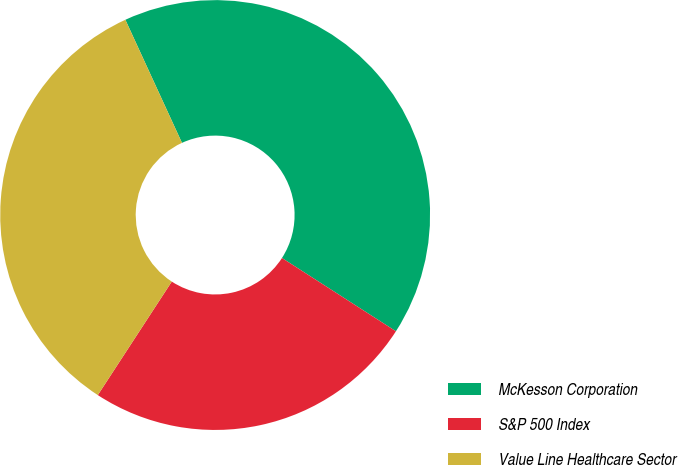Convert chart. <chart><loc_0><loc_0><loc_500><loc_500><pie_chart><fcel>McKesson Corporation<fcel>S&P 500 Index<fcel>Value Line Healthcare Sector<nl><fcel>40.96%<fcel>25.1%<fcel>33.95%<nl></chart> 